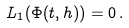<formula> <loc_0><loc_0><loc_500><loc_500>L _ { 1 } ( \Phi ( t , h ) ) = 0 \, .</formula> 